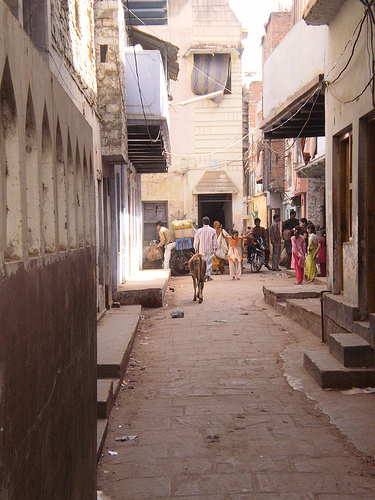<image>
Is the building in front of the building? Yes. The building is positioned in front of the building, appearing closer to the camera viewpoint. 